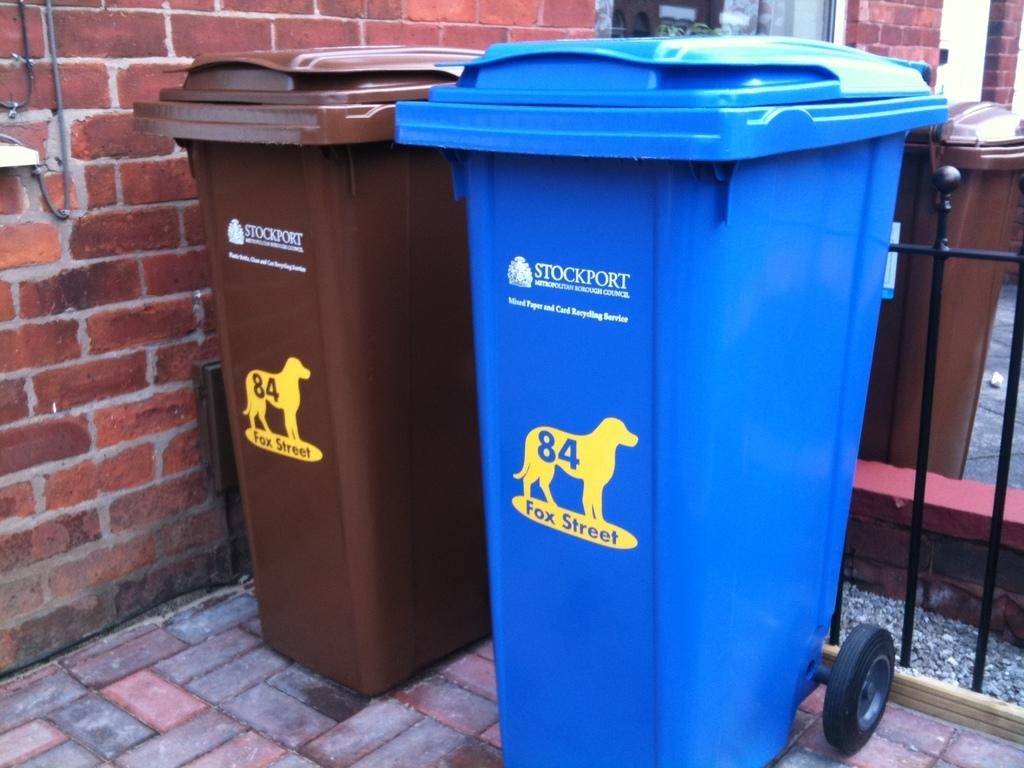<image>
Give a short and clear explanation of the subsequent image. The city on the garbage cans is Stockport 